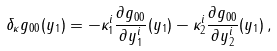<formula> <loc_0><loc_0><loc_500><loc_500>\delta _ { \kappa } g _ { 0 0 } ( y _ { 1 } ) = - \kappa _ { 1 } ^ { i } \frac { \partial g _ { 0 0 } } { \partial y _ { 1 } ^ { i } } ( y _ { 1 } ) - \kappa _ { 2 } ^ { i } \frac { \partial g _ { 0 0 } } { \partial y _ { 2 } ^ { i } } ( y _ { 1 } ) \, ,</formula> 